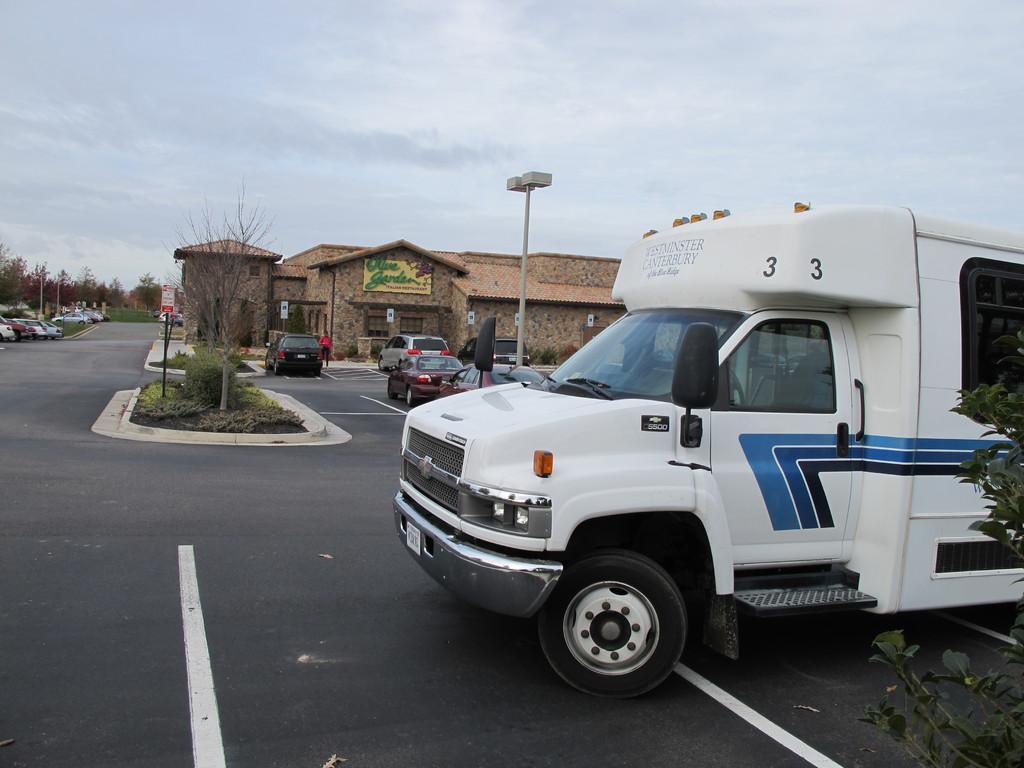Could you give a brief overview of what you see in this image? In this image we can able to see sky, there is a van over here, we can able to see tree here, and there are some cars here, and we can able to see road, and there is a tree here, and we can able to see a house and there is a board on it, and we can able to see a rod which consists of two lights, and we can able to see a sign board here. 